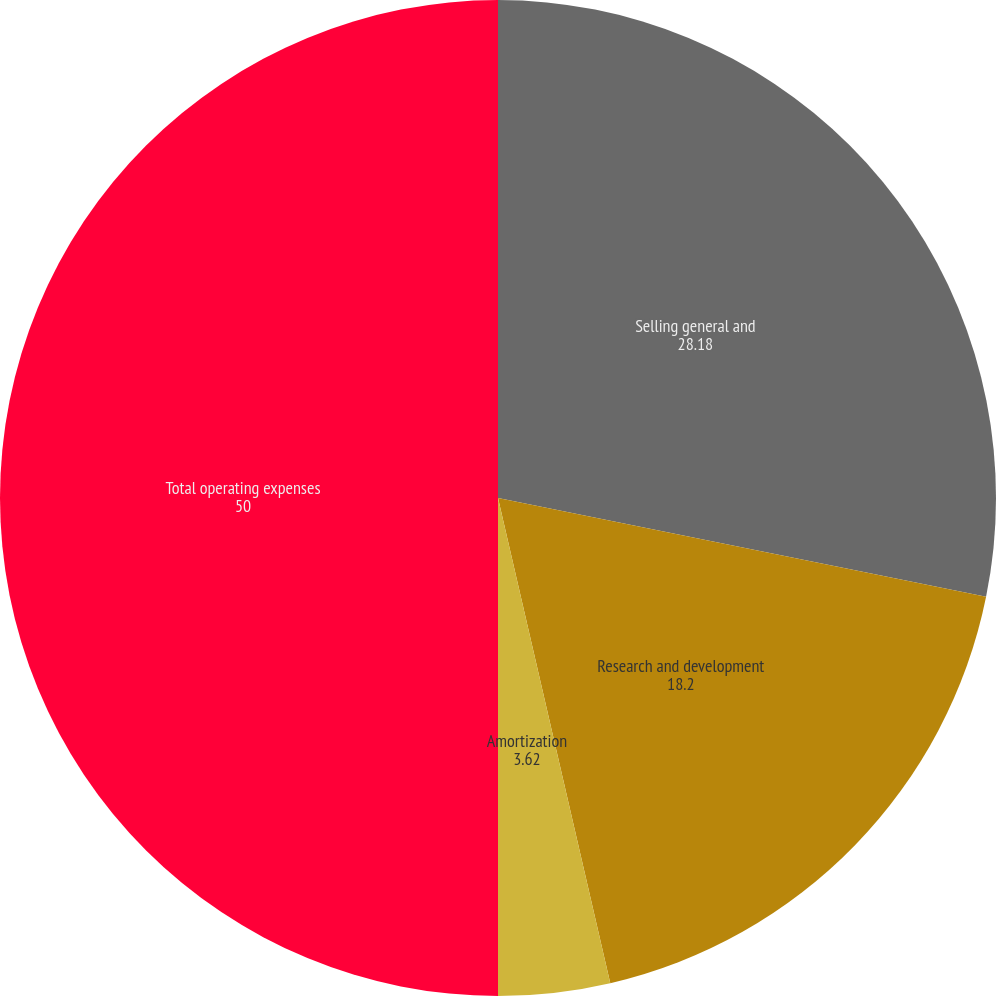<chart> <loc_0><loc_0><loc_500><loc_500><pie_chart><fcel>Selling general and<fcel>Research and development<fcel>Amortization<fcel>Total operating expenses<nl><fcel>28.18%<fcel>18.2%<fcel>3.62%<fcel>50.0%<nl></chart> 